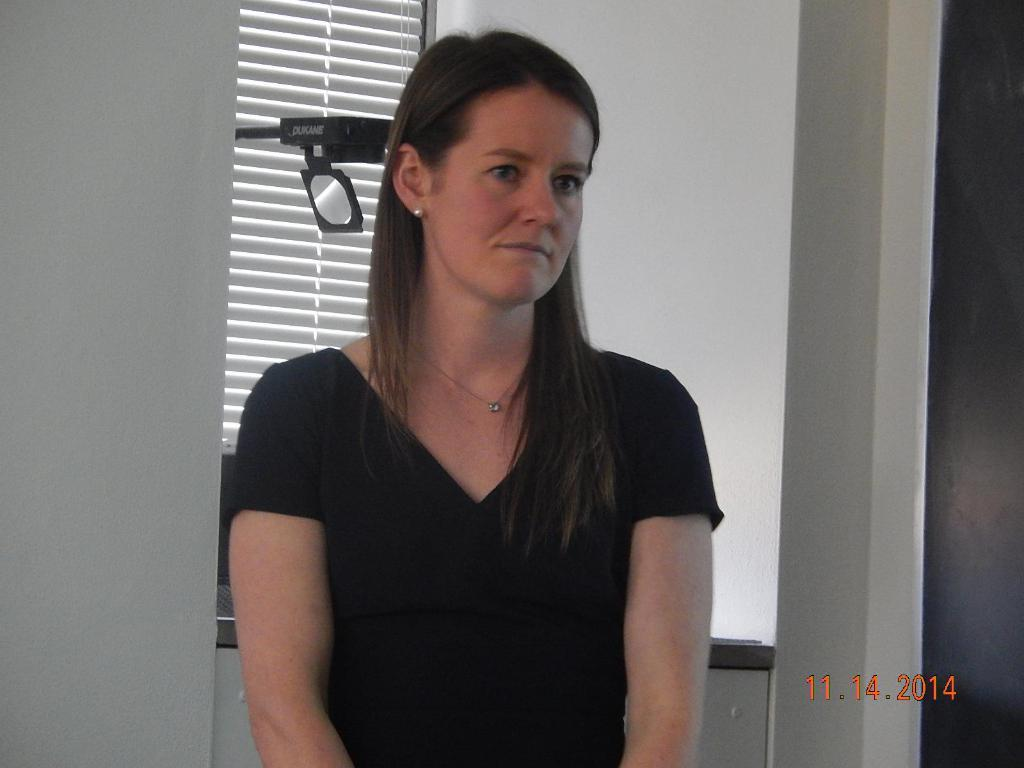Who is present in the image? There is a woman in the image. What is the woman wearing? The woman is wearing a black T-shirt. What can be seen in the background of the image? There is a wall in the background of the image. What type of toothpaste is the woman using in the image? There is no toothpaste present in the image, and the woman is not performing any activity that would involve toothpaste. 